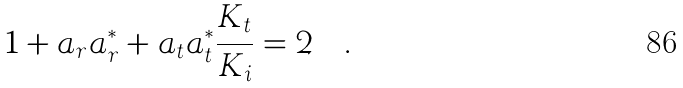<formula> <loc_0><loc_0><loc_500><loc_500>1 + a _ { r } a _ { r } ^ { * } + a _ { t } a _ { t } ^ { * } \frac { K _ { t } } { K _ { i } } = 2 \quad .</formula> 